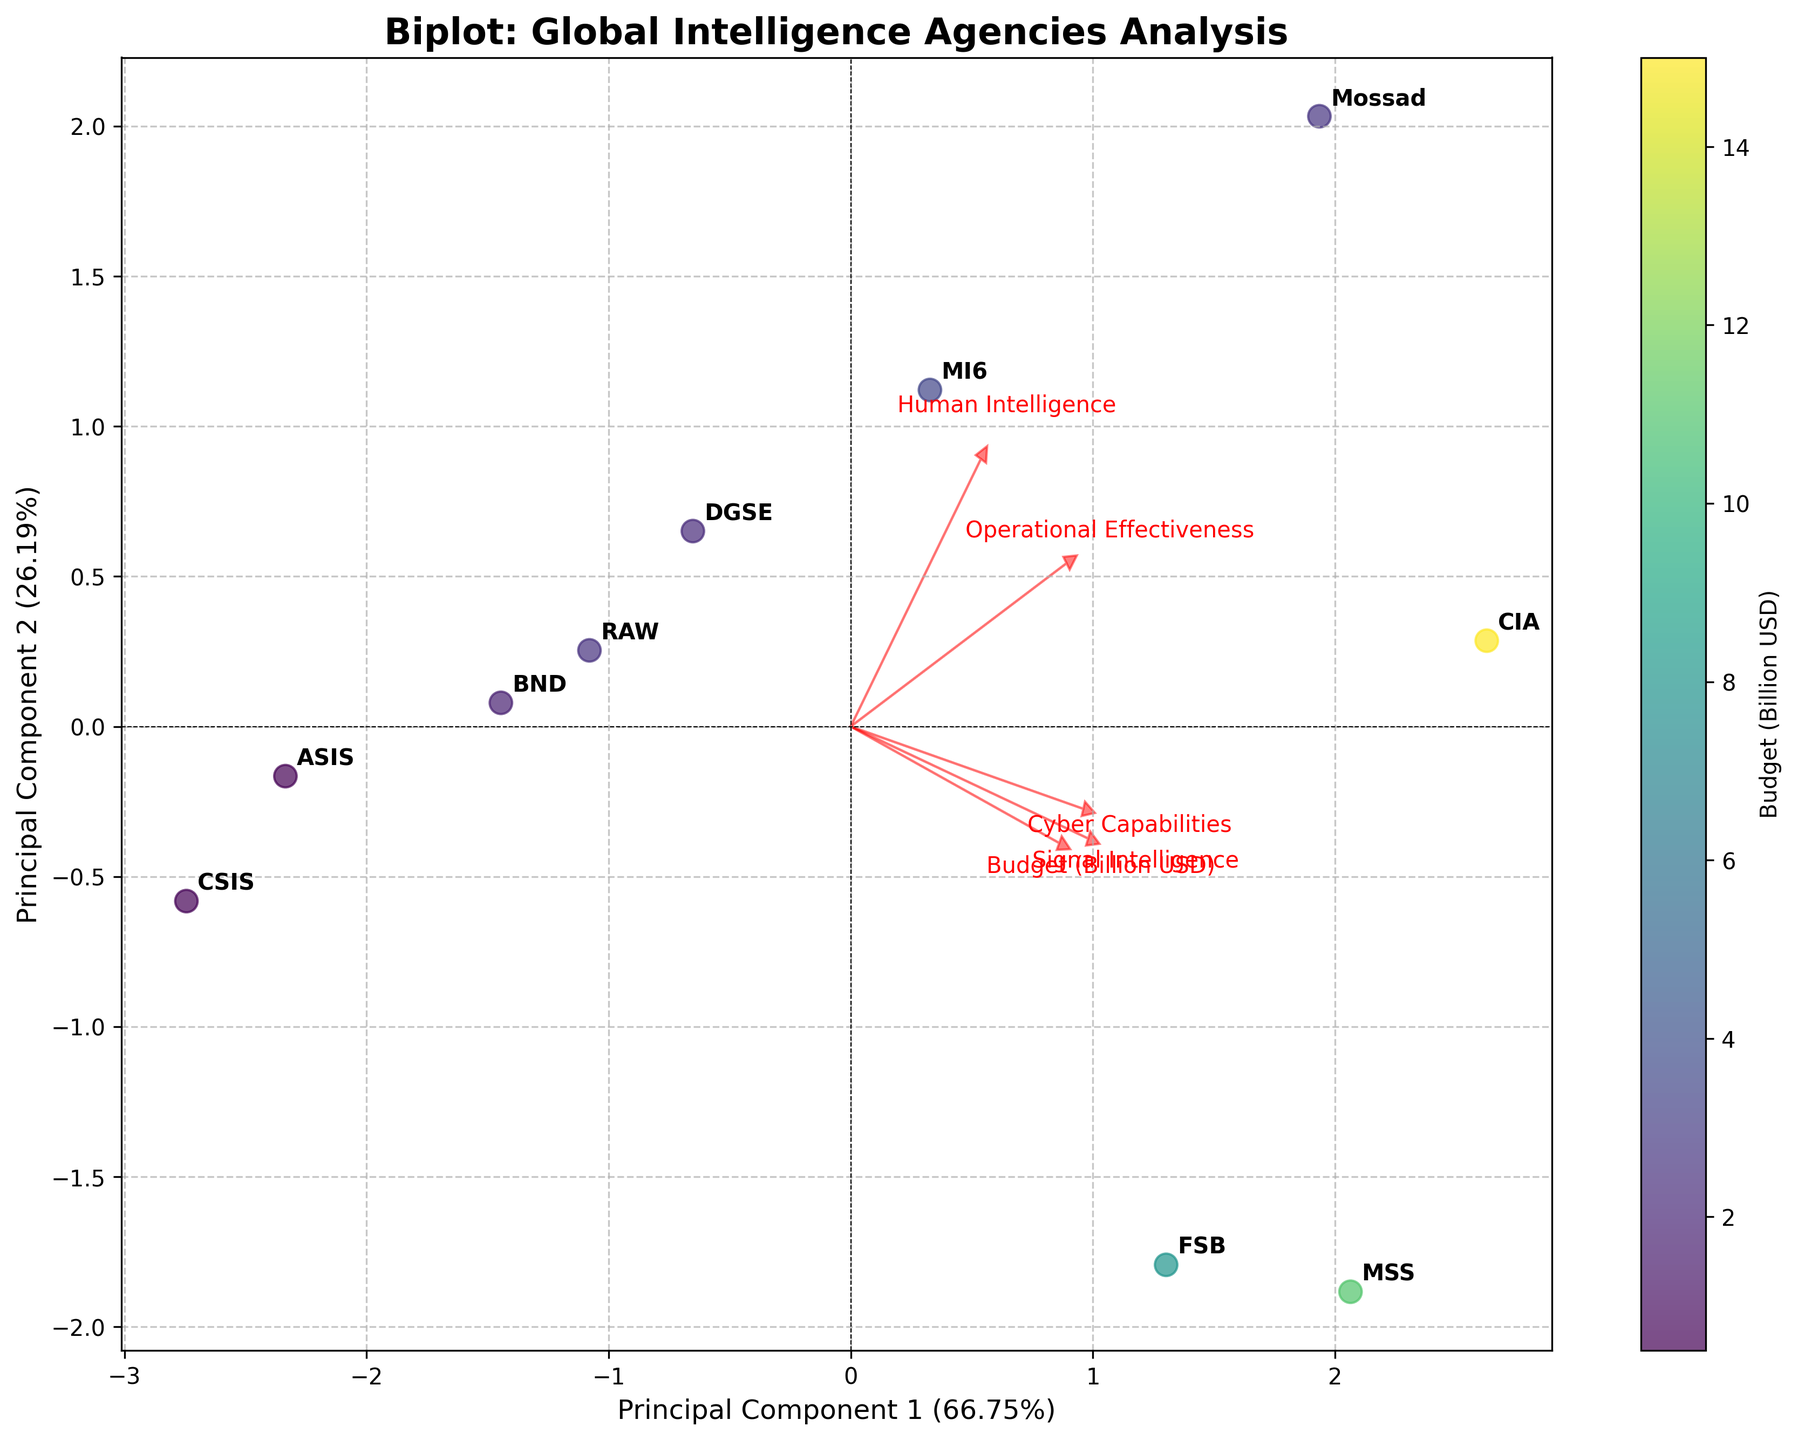what is the title of the plot? The title of the plot is clearly written at the top of the figure. It reads "Biplot: Global Intelligence Agencies Analysis".
Answer: Biplot: Global Intelligence Agencies Analysis What are the labels of the x-axis and y-axis? The x-axis label is "Principal Component 1" with the explained variance ratio stated in percentage. The y-axis label is "Principal Component 2" also with its explained variance ratio.
Answer: Principal Component 1 and Principal Component 2 How many data points are displayed in the plot? There are 10 intelligence agencies listed in the data, each represented as a data point in the plot.
Answer: 10 Which intelligence agency appears to have the highest operational effectiveness score? Mossad has the highest operational effectiveness score, as observed by its position relative to the operational effectiveness arrow.
Answer: Mossad Which feature contributes most to Principal Component 1 (PC1)? Looking at the direction and length of the feature arrows, the feature 'Budget (Billion USD)' contributes the most to PC1.
Answer: Budget (Billion USD) Which agency has a relatively high combination of signal intelligence and cyber capabilities? MSS has a relatively high combination of signal intelligence and cyber capabilities, as indicated by its position in the direction of these features' arrows.
Answer: MSS Which agencies have their data points closely positioned together in the plot? DGSE, BND, and ASIS have their data points closely positioned together in the plot. They lie near one another in the lower left region.
Answer: DGSE, BND, and ASIS Is there a noticeable trade-off between budget and operational effectiveness among the agencies? There is no direct visible trade-off. Agencies with higher budgets like CIA and MSS also show high operational effectiveness, but agencies with lower budgets like Mossad also exhibit high operational effectiveness.
Answer: No What percentage of the variance is explained by the first two principal components? The x-axis label states the explained variance ratio for PC1 and the y-axis label states that for PC2. Summing these percentages gives the total variance explained by the first two principal components.
Answer: PC1 + PC2 percentages Does MI6 show a high score in human intelligence compared to other agencies? Yes, MI6 shows a high score in human intelligence, as indicated by its position relative to the 'Human Intelligence' arrow.
Answer: Yes 